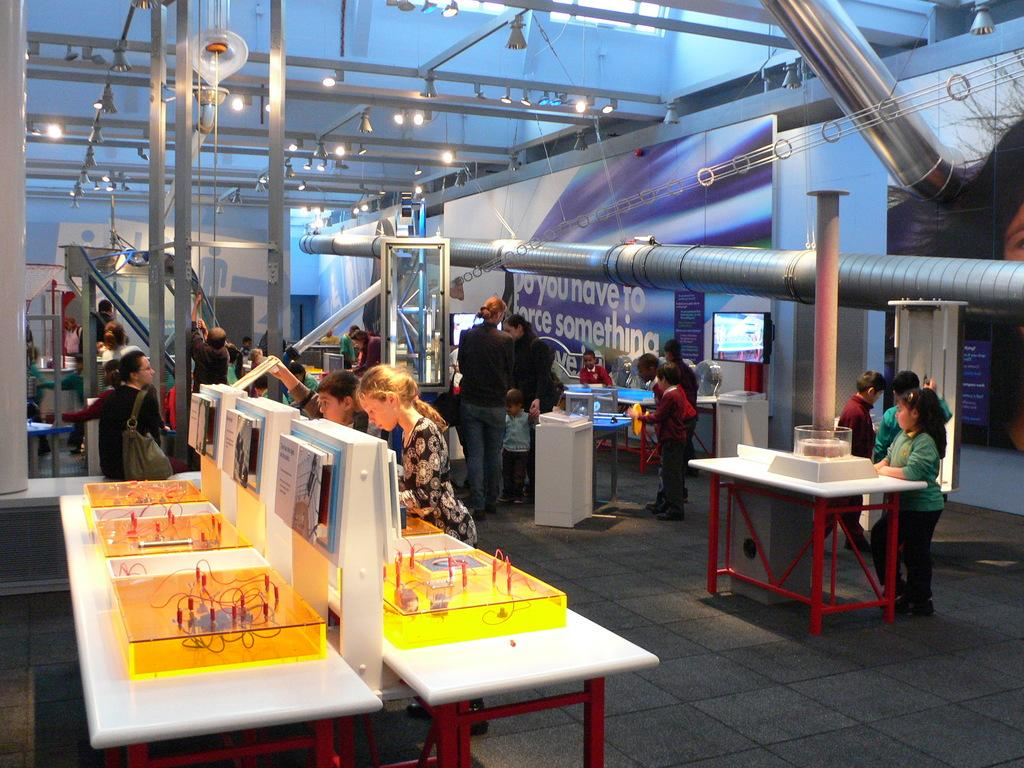How many people are in the image? There are people in the image, but the exact number is not specified. Where are the people located in the image? The people are standing in a room. What are the people doing in the image? The people are operating electrical boards. What type of cakes are being served during the argument in the image? There is no mention of an argument or cakes in the image; the people are operating electrical boards in a room. 